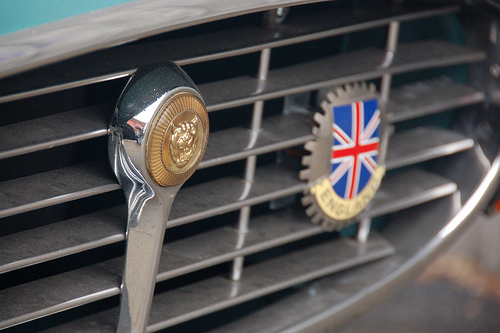<image>
Is the flag above the vehicle? No. The flag is not positioned above the vehicle. The vertical arrangement shows a different relationship. Is there a emblem above the grill? No. The emblem is not positioned above the grill. The vertical arrangement shows a different relationship. 